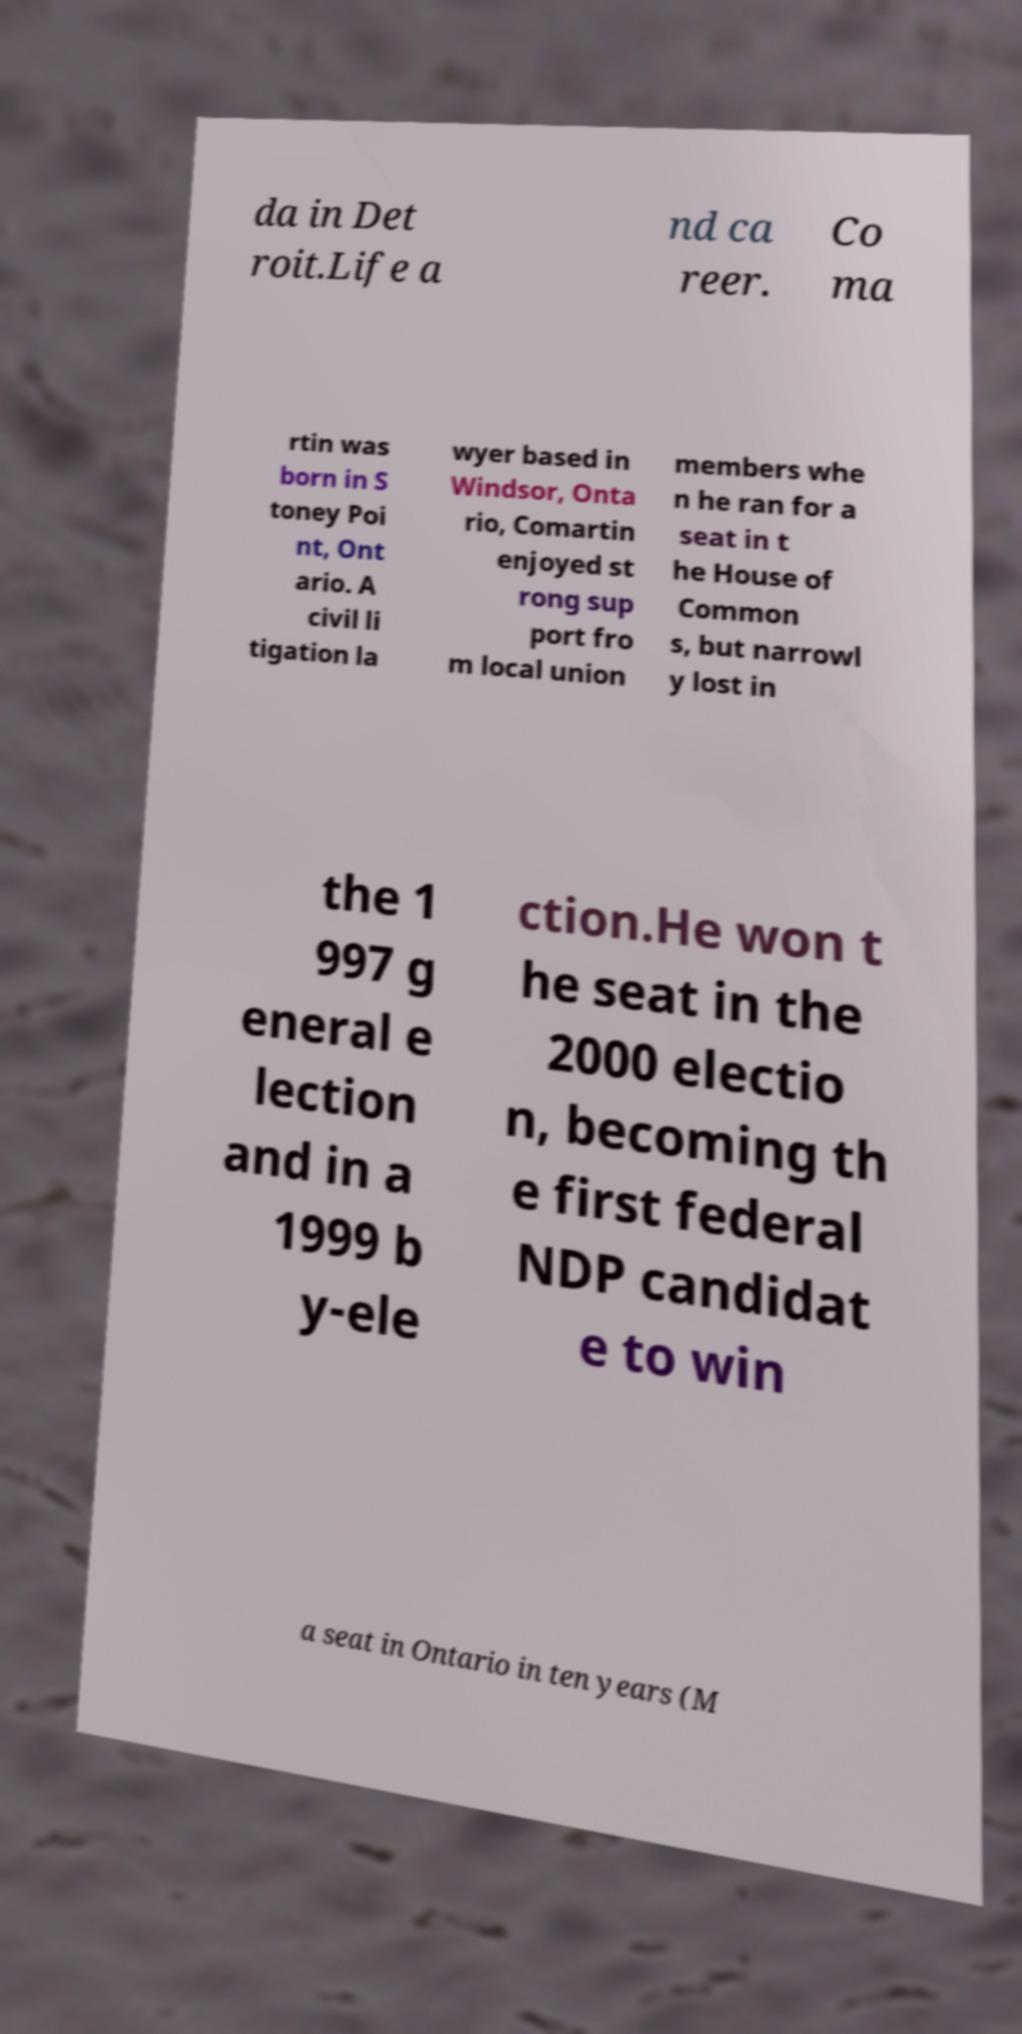Could you extract and type out the text from this image? da in Det roit.Life a nd ca reer. Co ma rtin was born in S toney Poi nt, Ont ario. A civil li tigation la wyer based in Windsor, Onta rio, Comartin enjoyed st rong sup port fro m local union members whe n he ran for a seat in t he House of Common s, but narrowl y lost in the 1 997 g eneral e lection and in a 1999 b y-ele ction.He won t he seat in the 2000 electio n, becoming th e first federal NDP candidat e to win a seat in Ontario in ten years (M 